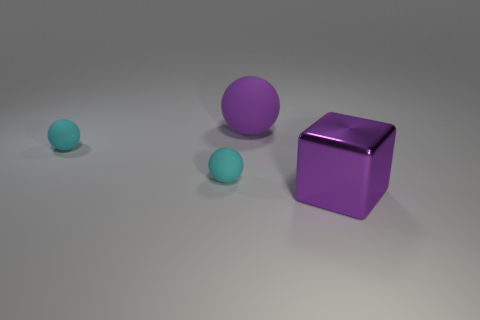If these objects were part of a story, what genre do you think it would be and why? The simplicity and bold colors suggest a story fitting within a science fiction or fantasy genre, where the spheres could be mystical entities on a journey to align with the powerful cube that guards the knowledge of their universe. 